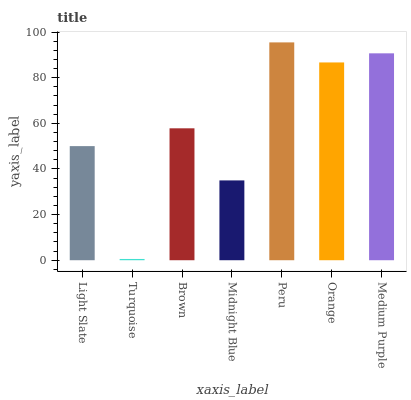Is Turquoise the minimum?
Answer yes or no. Yes. Is Peru the maximum?
Answer yes or no. Yes. Is Brown the minimum?
Answer yes or no. No. Is Brown the maximum?
Answer yes or no. No. Is Brown greater than Turquoise?
Answer yes or no. Yes. Is Turquoise less than Brown?
Answer yes or no. Yes. Is Turquoise greater than Brown?
Answer yes or no. No. Is Brown less than Turquoise?
Answer yes or no. No. Is Brown the high median?
Answer yes or no. Yes. Is Brown the low median?
Answer yes or no. Yes. Is Midnight Blue the high median?
Answer yes or no. No. Is Midnight Blue the low median?
Answer yes or no. No. 